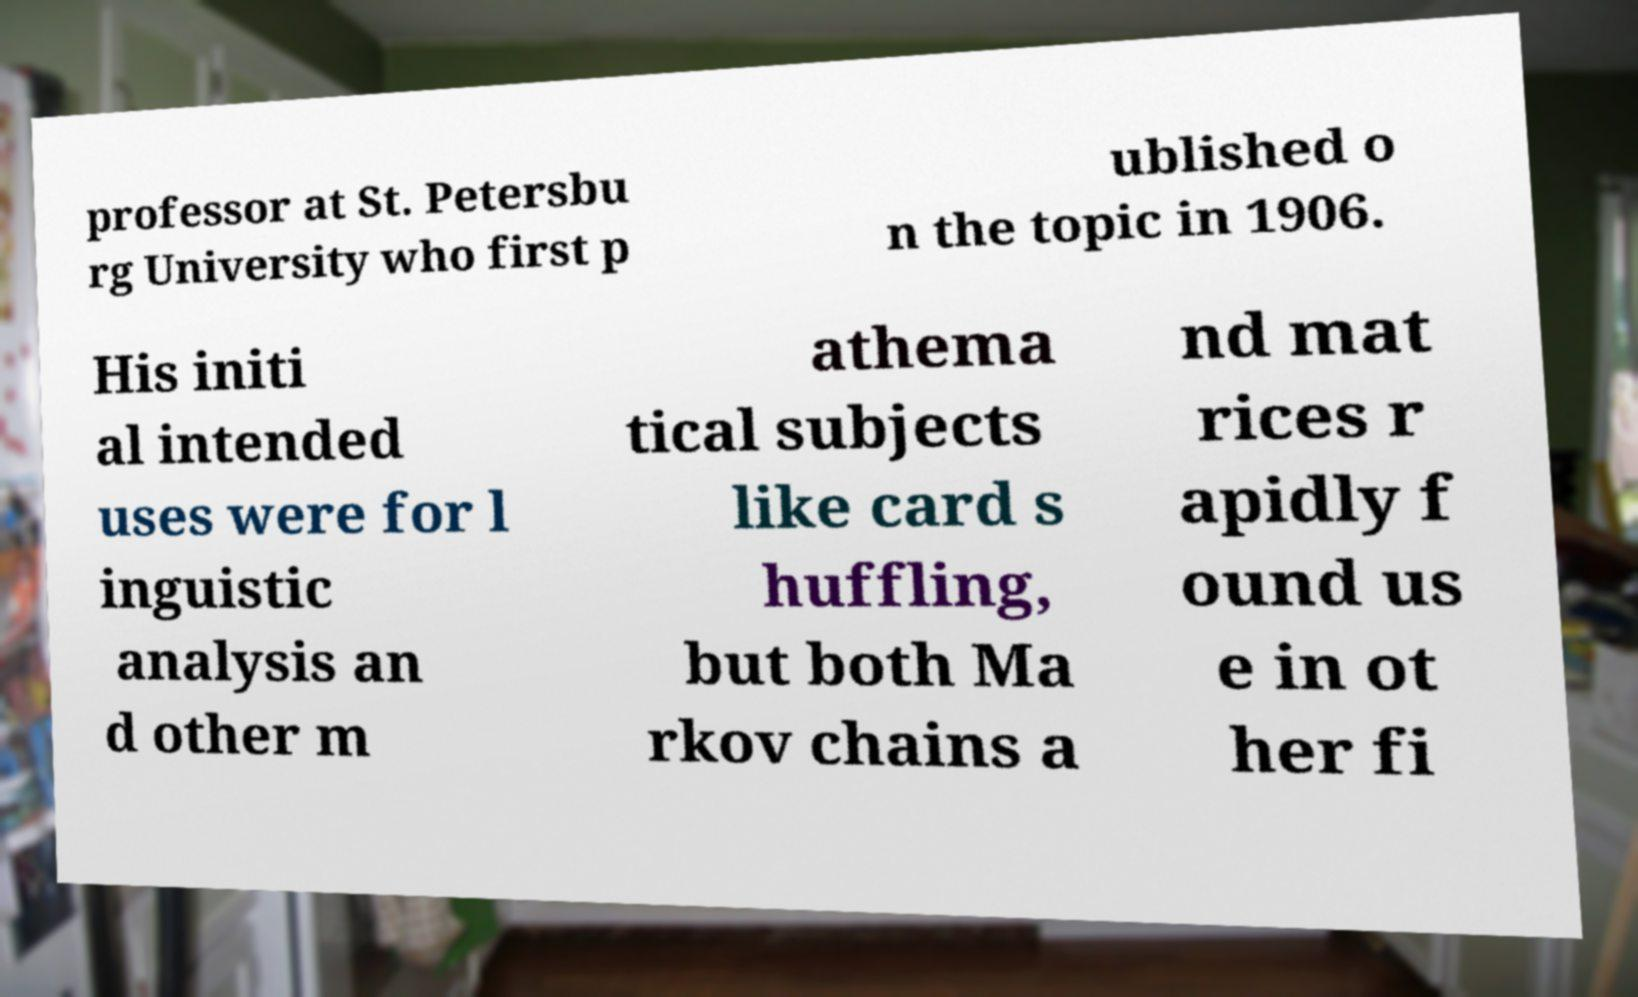I need the written content from this picture converted into text. Can you do that? professor at St. Petersbu rg University who first p ublished o n the topic in 1906. His initi al intended uses were for l inguistic analysis an d other m athema tical subjects like card s huffling, but both Ma rkov chains a nd mat rices r apidly f ound us e in ot her fi 